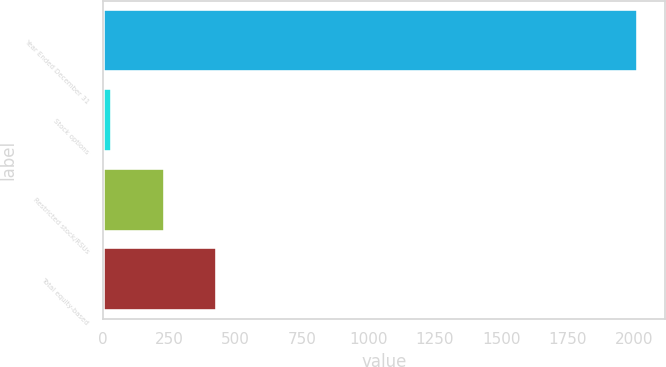Convert chart. <chart><loc_0><loc_0><loc_500><loc_500><bar_chart><fcel>Year Ended December 31<fcel>Stock options<fcel>Restricted stock/RSUs<fcel>Total equity-based<nl><fcel>2017<fcel>34<fcel>232.3<fcel>430.6<nl></chart> 